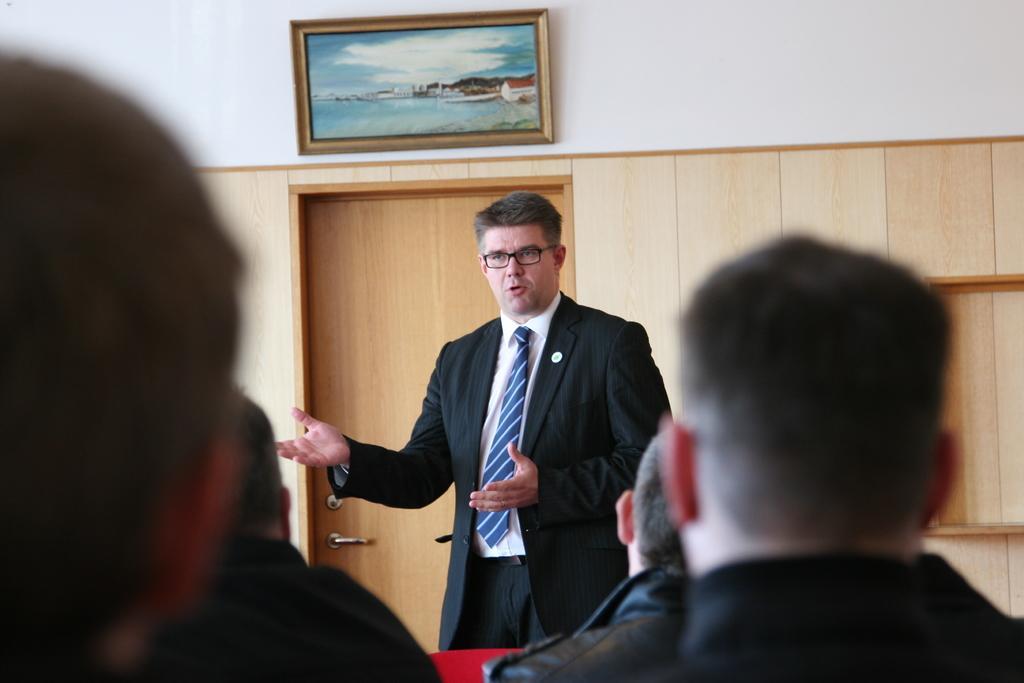In one or two sentences, can you explain what this image depicts? In this image there is a man in the middle. In front of him there are few other people who are sitting in the chairs. In the background there is a door. Above the door there is a photo frame. 